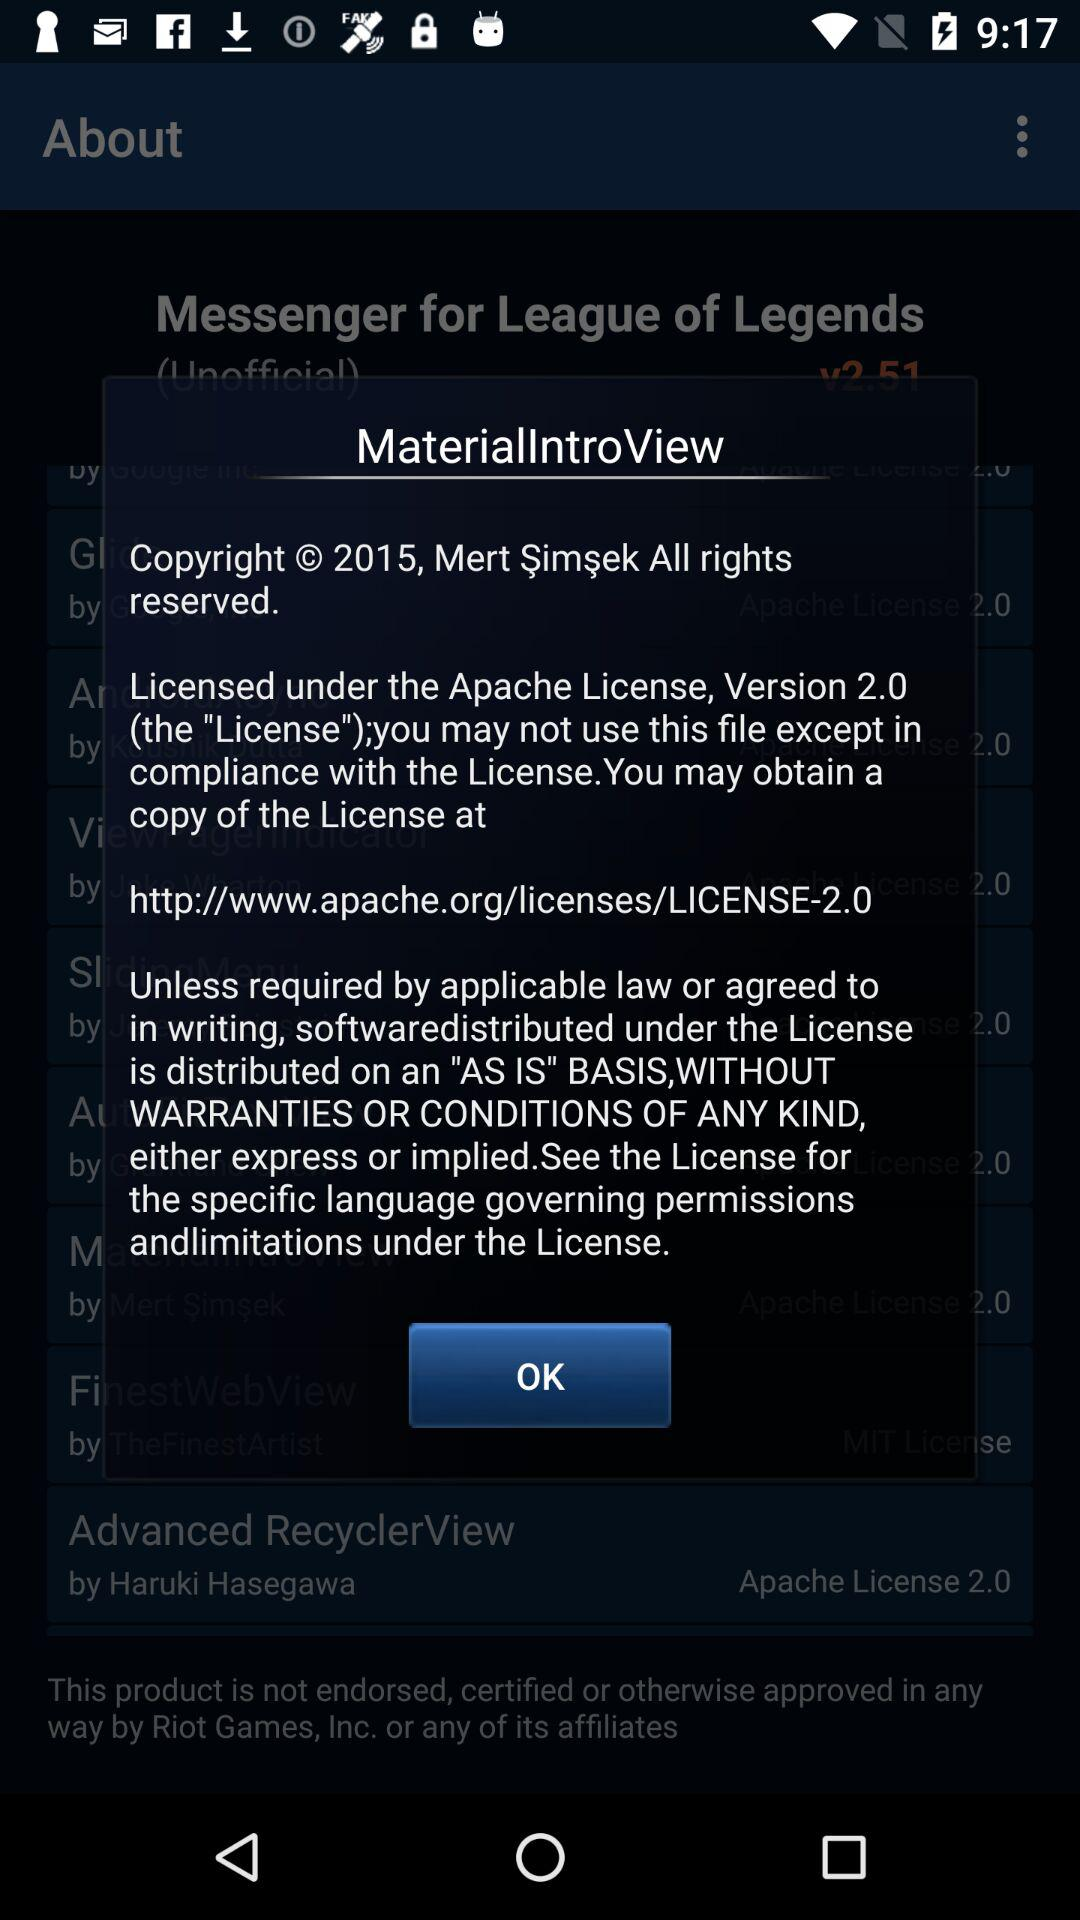What is the version of the application?
When the provided information is insufficient, respond with <no answer>. <no answer> 